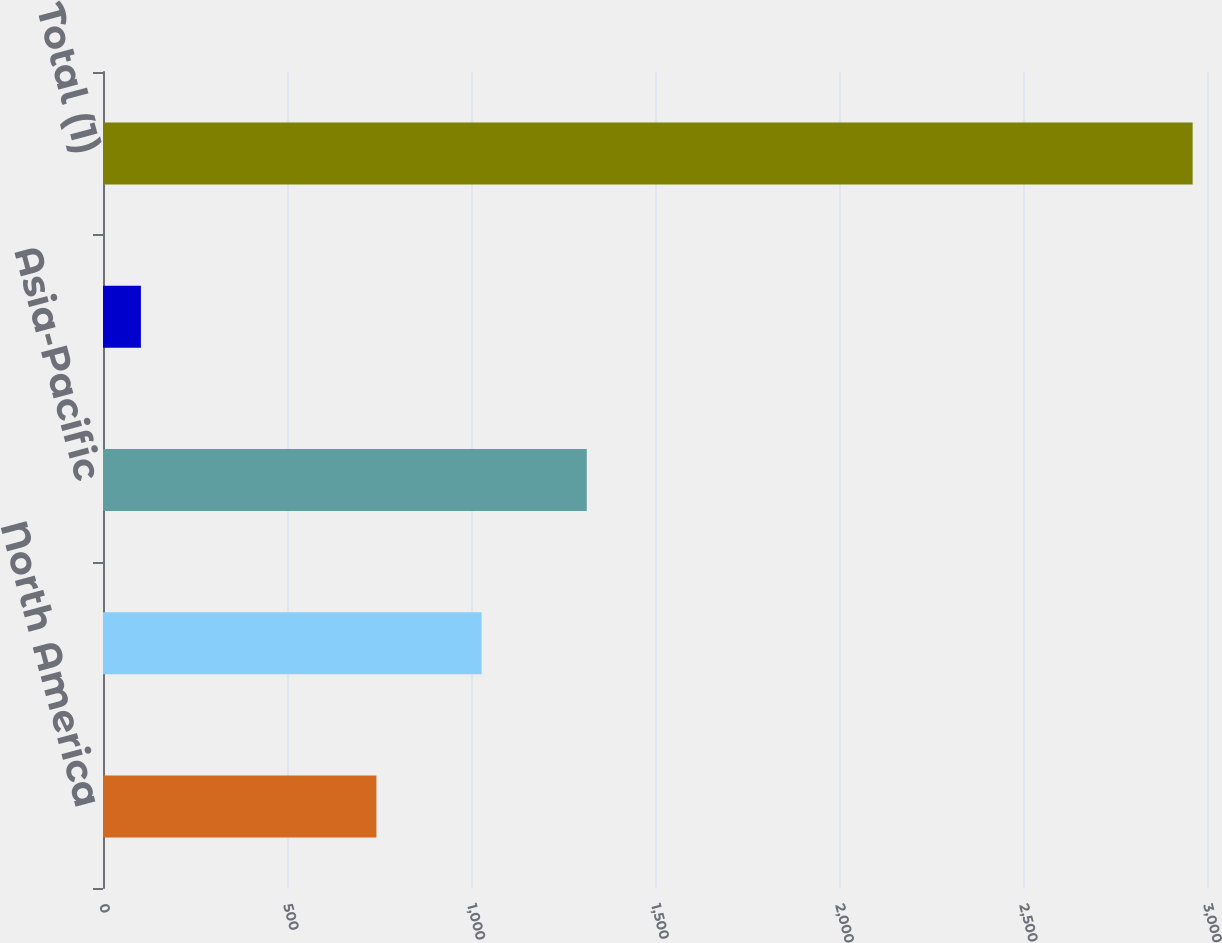Convert chart to OTSL. <chart><loc_0><loc_0><loc_500><loc_500><bar_chart><fcel>North America<fcel>Europe and Africa<fcel>Asia-Pacific<fcel>South America<fcel>Total (1)<nl><fcel>743<fcel>1028.8<fcel>1314.6<fcel>103<fcel>2961<nl></chart> 